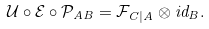<formula> <loc_0><loc_0><loc_500><loc_500>\mathcal { U } \circ \mathcal { E } \circ \mathcal { P } _ { A B } = \mathcal { F } _ { C | A } \otimes i d _ { B } .</formula> 